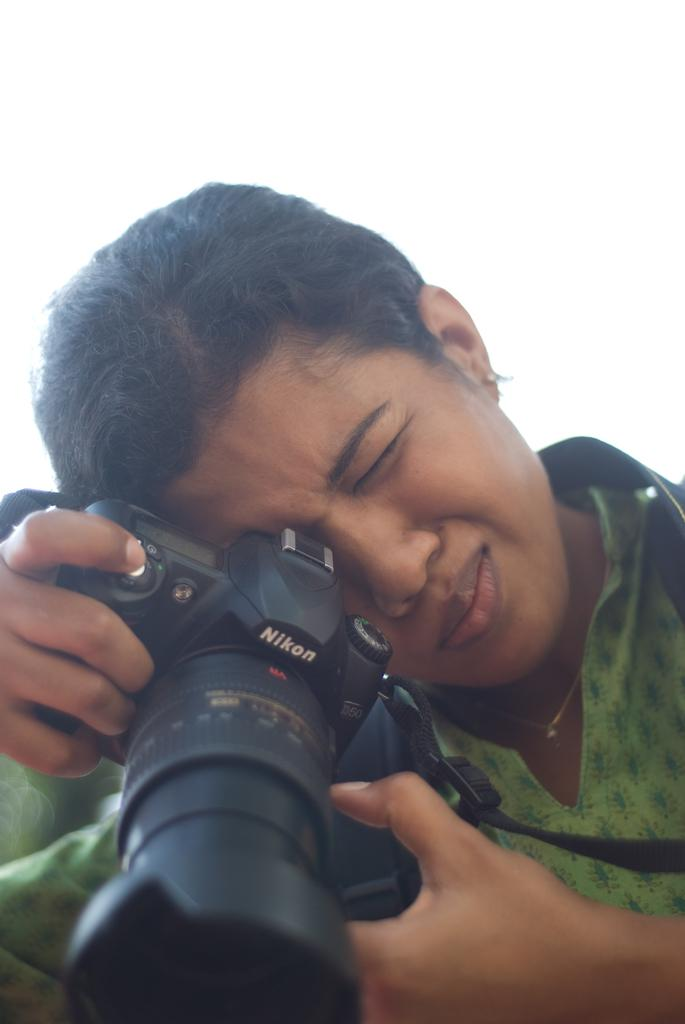Who is the main subject in the image? There is a woman in the image. What is the woman holding in the image? The woman is holding a camera. What might the woman be trying to do with the camera? The woman is trying to capture something with the camera. What type of veil is the woman wearing in the image? There is no veil present in the image; the woman is holding a camera. 